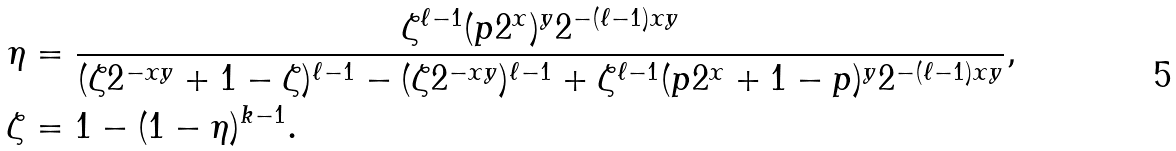<formula> <loc_0><loc_0><loc_500><loc_500>\eta & = \frac { \zeta ^ { \ell - 1 } ( p 2 ^ { x } ) ^ { y } 2 ^ { - ( \ell - 1 ) x y } } { ( \zeta 2 ^ { - x y } + 1 - \zeta ) ^ { \ell - 1 } - ( \zeta 2 ^ { - x y } ) ^ { \ell - 1 } + \zeta ^ { \ell - 1 } ( p 2 ^ { x } + 1 - p ) ^ { y } 2 ^ { - ( \ell - 1 ) x y } } , \\ \zeta & = 1 - ( 1 - \eta ) ^ { k - 1 } .</formula> 